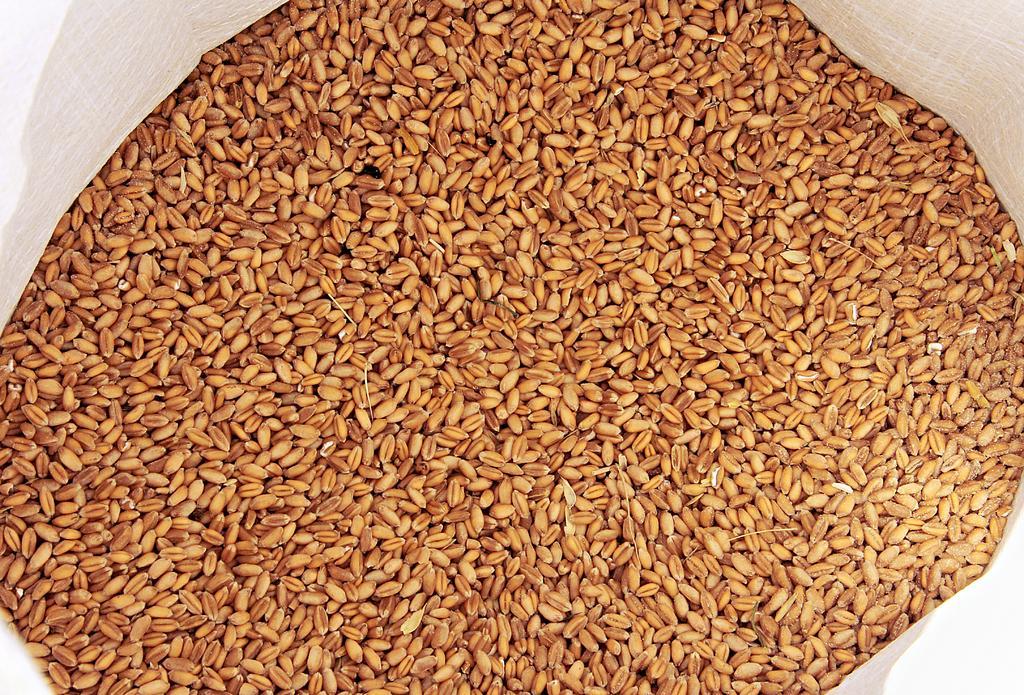Can you describe this image briefly? In the foreground of this image, there are wheat and it seems to be in a white bag. 